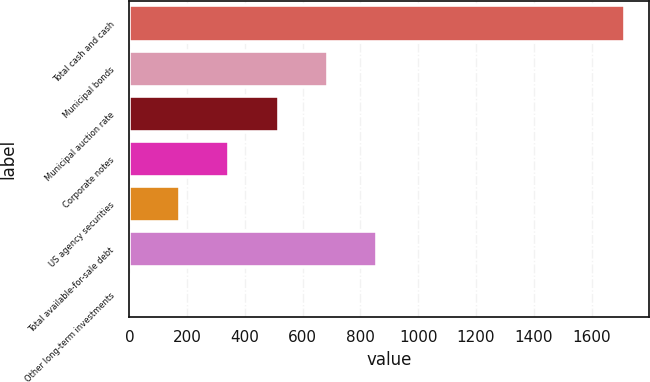Convert chart to OTSL. <chart><loc_0><loc_0><loc_500><loc_500><bar_chart><fcel>Total cash and cash<fcel>Municipal bonds<fcel>Municipal auction rate<fcel>Corporate notes<fcel>US agency securities<fcel>Total available-for-sale debt<fcel>Other long-term investments<nl><fcel>1714<fcel>687.4<fcel>516.3<fcel>345.2<fcel>174.1<fcel>858.5<fcel>3<nl></chart> 